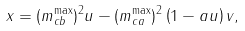Convert formula to latex. <formula><loc_0><loc_0><loc_500><loc_500>x = ( m _ { c b } ^ { \max } ) ^ { 2 } u - ( m _ { c a } ^ { \max } ) ^ { 2 } \left ( 1 - a u \right ) v ,</formula> 